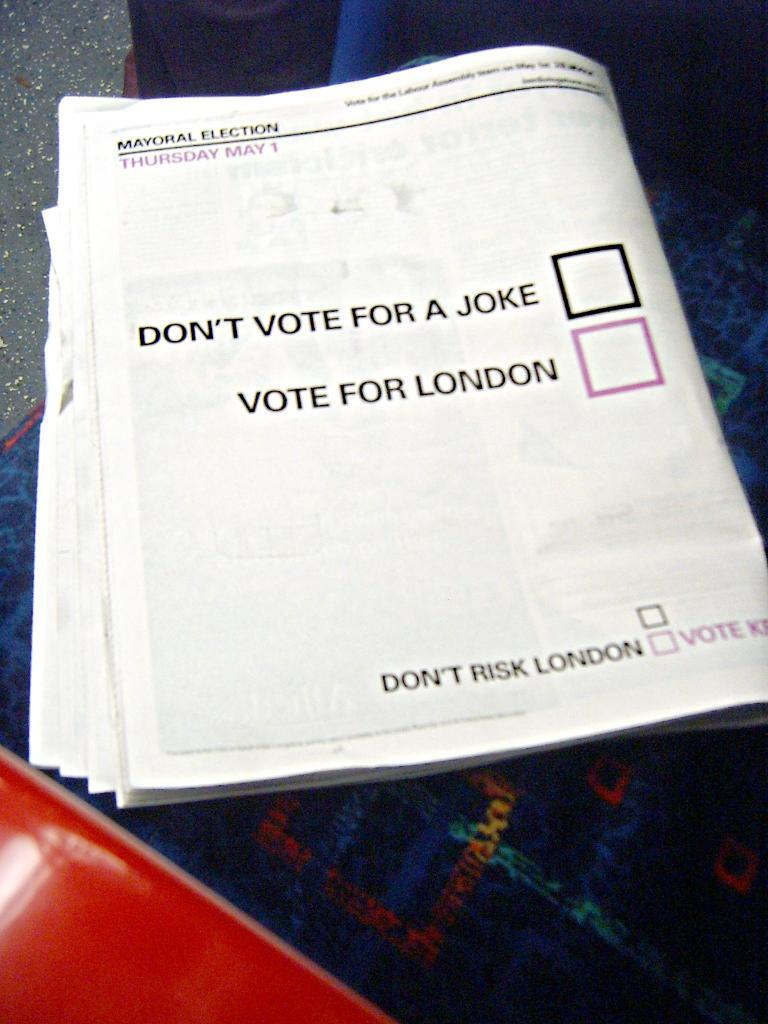<image>
Present a compact description of the photo's key features. the word joke that is on a paper 